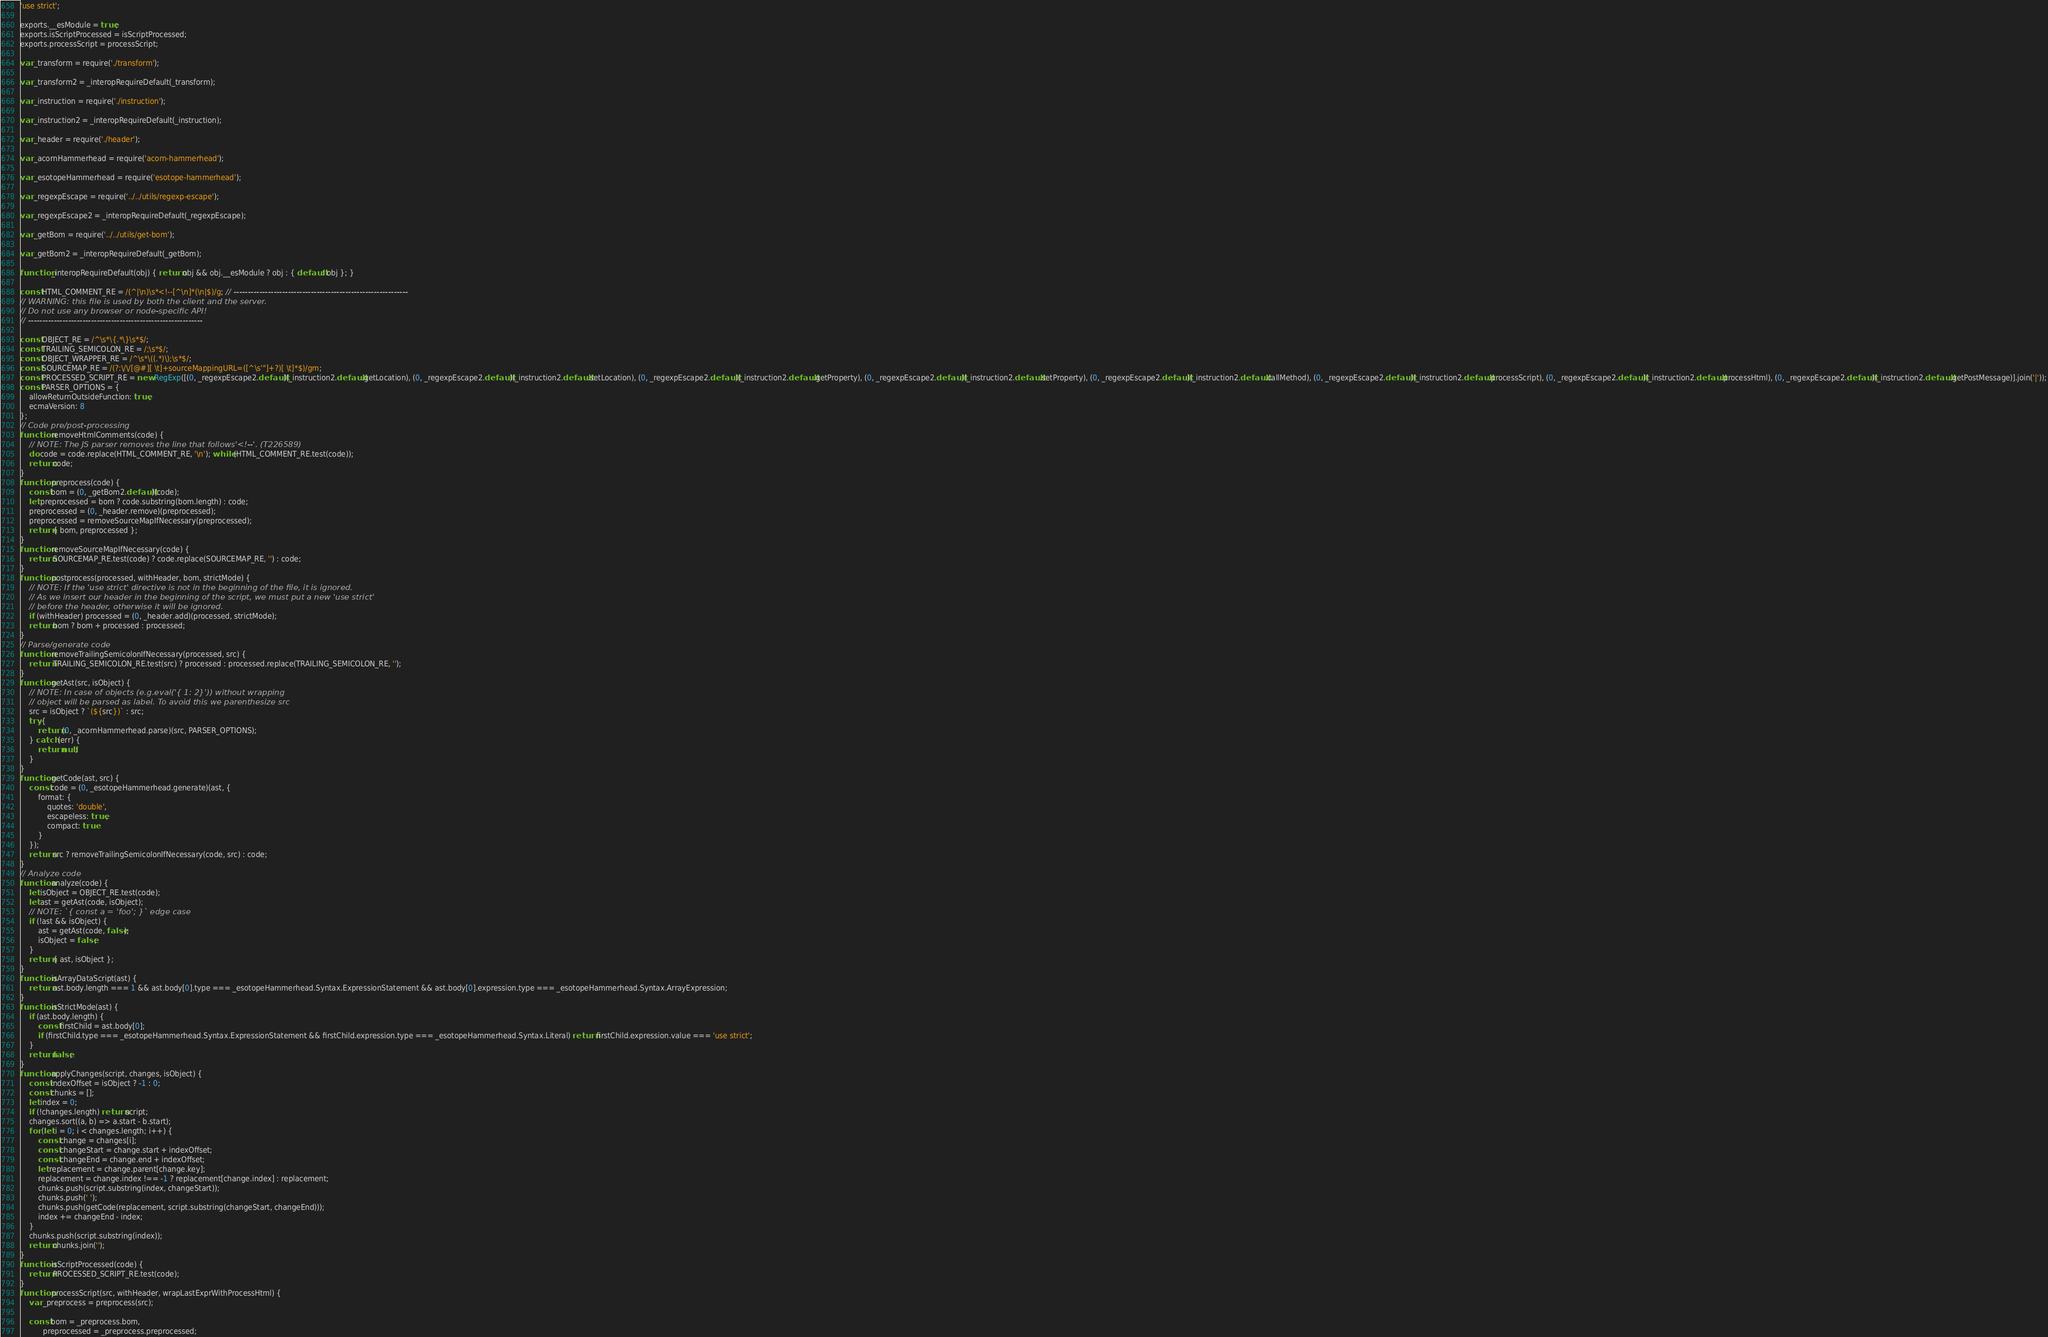<code> <loc_0><loc_0><loc_500><loc_500><_JavaScript_>'use strict';

exports.__esModule = true;
exports.isScriptProcessed = isScriptProcessed;
exports.processScript = processScript;

var _transform = require('./transform');

var _transform2 = _interopRequireDefault(_transform);

var _instruction = require('./instruction');

var _instruction2 = _interopRequireDefault(_instruction);

var _header = require('./header');

var _acornHammerhead = require('acorn-hammerhead');

var _esotopeHammerhead = require('esotope-hammerhead');

var _regexpEscape = require('../../utils/regexp-escape');

var _regexpEscape2 = _interopRequireDefault(_regexpEscape);

var _getBom = require('../../utils/get-bom');

var _getBom2 = _interopRequireDefault(_getBom);

function _interopRequireDefault(obj) { return obj && obj.__esModule ? obj : { default: obj }; }

const HTML_COMMENT_RE = /(^|\n)\s*<!--[^\n]*(\n|$)/g; // -------------------------------------------------------------
// WARNING: this file is used by both the client and the server.
// Do not use any browser or node-specific API!
// -------------------------------------------------------------

const OBJECT_RE = /^\s*\{.*\}\s*$/;
const TRAILING_SEMICOLON_RE = /;\s*$/;
const OBJECT_WRAPPER_RE = /^\s*\((.*)\);\s*$/;
const SOURCEMAP_RE = /(?:\/\/[@#][ \t]+sourceMappingURL=([^\s'"]+?)[ \t]*$)/gm;
const PROCESSED_SCRIPT_RE = new RegExp([(0, _regexpEscape2.default)(_instruction2.default.getLocation), (0, _regexpEscape2.default)(_instruction2.default.setLocation), (0, _regexpEscape2.default)(_instruction2.default.getProperty), (0, _regexpEscape2.default)(_instruction2.default.setProperty), (0, _regexpEscape2.default)(_instruction2.default.callMethod), (0, _regexpEscape2.default)(_instruction2.default.processScript), (0, _regexpEscape2.default)(_instruction2.default.processHtml), (0, _regexpEscape2.default)(_instruction2.default.getPostMessage)].join('|'));
const PARSER_OPTIONS = {
    allowReturnOutsideFunction: true,
    ecmaVersion: 8
};
// Code pre/post-processing
function removeHtmlComments(code) {
    // NOTE: The JS parser removes the line that follows'<!--'. (T226589)
    do code = code.replace(HTML_COMMENT_RE, '\n'); while (HTML_COMMENT_RE.test(code));
    return code;
}
function preprocess(code) {
    const bom = (0, _getBom2.default)(code);
    let preprocessed = bom ? code.substring(bom.length) : code;
    preprocessed = (0, _header.remove)(preprocessed);
    preprocessed = removeSourceMapIfNecessary(preprocessed);
    return { bom, preprocessed };
}
function removeSourceMapIfNecessary(code) {
    return SOURCEMAP_RE.test(code) ? code.replace(SOURCEMAP_RE, '') : code;
}
function postprocess(processed, withHeader, bom, strictMode) {
    // NOTE: If the 'use strict' directive is not in the beginning of the file, it is ignored.
    // As we insert our header in the beginning of the script, we must put a new 'use strict'
    // before the header, otherwise it will be ignored.
    if (withHeader) processed = (0, _header.add)(processed, strictMode);
    return bom ? bom + processed : processed;
}
// Parse/generate code
function removeTrailingSemicolonIfNecessary(processed, src) {
    return TRAILING_SEMICOLON_RE.test(src) ? processed : processed.replace(TRAILING_SEMICOLON_RE, '');
}
function getAst(src, isObject) {
    // NOTE: In case of objects (e.g.eval('{ 1: 2}')) without wrapping
    // object will be parsed as label. To avoid this we parenthesize src
    src = isObject ? `(${src})` : src;
    try {
        return (0, _acornHammerhead.parse)(src, PARSER_OPTIONS);
    } catch (err) {
        return null;
    }
}
function getCode(ast, src) {
    const code = (0, _esotopeHammerhead.generate)(ast, {
        format: {
            quotes: 'double',
            escapeless: true,
            compact: true
        }
    });
    return src ? removeTrailingSemicolonIfNecessary(code, src) : code;
}
// Analyze code
function analyze(code) {
    let isObject = OBJECT_RE.test(code);
    let ast = getAst(code, isObject);
    // NOTE: `{ const a = 'foo'; }` edge case
    if (!ast && isObject) {
        ast = getAst(code, false);
        isObject = false;
    }
    return { ast, isObject };
}
function isArrayDataScript(ast) {
    return ast.body.length === 1 && ast.body[0].type === _esotopeHammerhead.Syntax.ExpressionStatement && ast.body[0].expression.type === _esotopeHammerhead.Syntax.ArrayExpression;
}
function isStrictMode(ast) {
    if (ast.body.length) {
        const firstChild = ast.body[0];
        if (firstChild.type === _esotopeHammerhead.Syntax.ExpressionStatement && firstChild.expression.type === _esotopeHammerhead.Syntax.Literal) return firstChild.expression.value === 'use strict';
    }
    return false;
}
function applyChanges(script, changes, isObject) {
    const indexOffset = isObject ? -1 : 0;
    const chunks = [];
    let index = 0;
    if (!changes.length) return script;
    changes.sort((a, b) => a.start - b.start);
    for (let i = 0; i < changes.length; i++) {
        const change = changes[i];
        const changeStart = change.start + indexOffset;
        const changeEnd = change.end + indexOffset;
        let replacement = change.parent[change.key];
        replacement = change.index !== -1 ? replacement[change.index] : replacement;
        chunks.push(script.substring(index, changeStart));
        chunks.push(' ');
        chunks.push(getCode(replacement, script.substring(changeStart, changeEnd)));
        index += changeEnd - index;
    }
    chunks.push(script.substring(index));
    return chunks.join('');
}
function isScriptProcessed(code) {
    return PROCESSED_SCRIPT_RE.test(code);
}
function processScript(src, withHeader, wrapLastExprWithProcessHtml) {
    var _preprocess = preprocess(src);

    const bom = _preprocess.bom,
          preprocessed = _preprocess.preprocessed;
</code> 